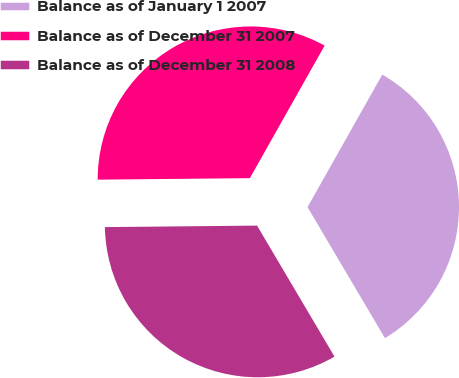<chart> <loc_0><loc_0><loc_500><loc_500><pie_chart><fcel>Balance as of January 1 2007<fcel>Balance as of December 31 2007<fcel>Balance as of December 31 2008<nl><fcel>33.33%<fcel>33.33%<fcel>33.34%<nl></chart> 